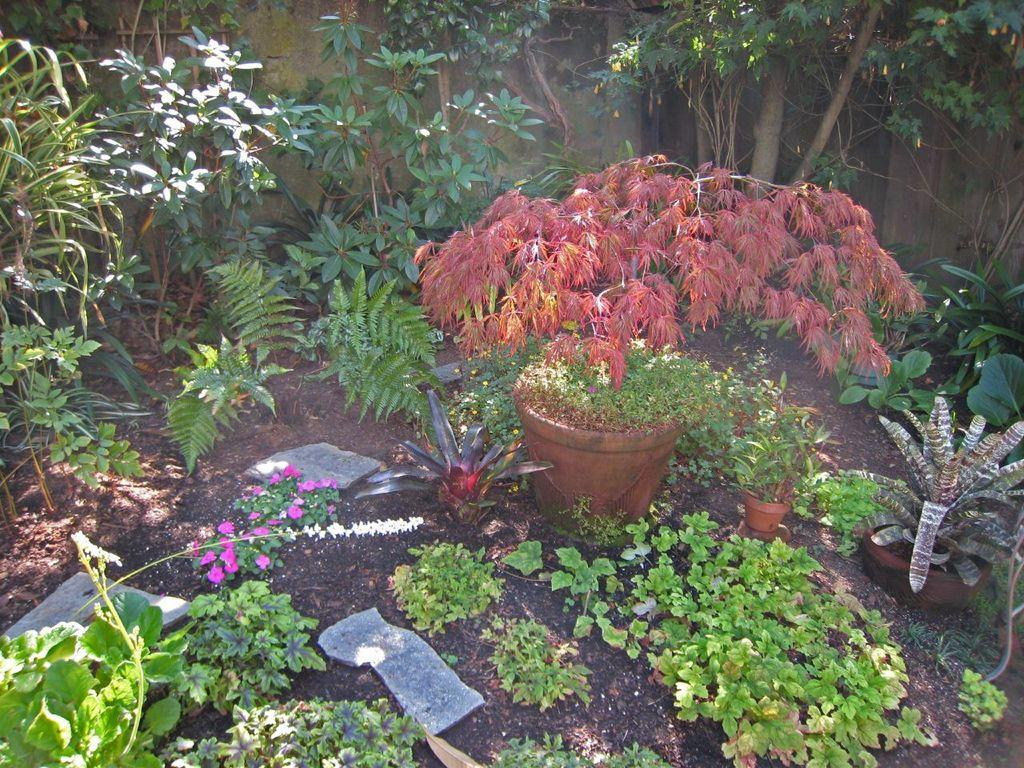What type of living organisms can be seen in the image? Plants and flowers are visible in the image. What are the plants contained in? There are pots in the image. What can be seen growing on the plants? Flowers are visible in the image. What is visible in the background of the image? There is a wall in the background of the image. What type of decision can be seen being made by the drum in the image? There is no drum present in the image, so it is not possible to determine if any decisions are being made. 